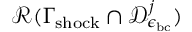Convert formula to latex. <formula><loc_0><loc_0><loc_500><loc_500>\mathcal { R } ( \Gamma _ { s h o c k } \cap \mathcal { D } _ { \epsilon _ { b c } } ^ { j } )</formula> 